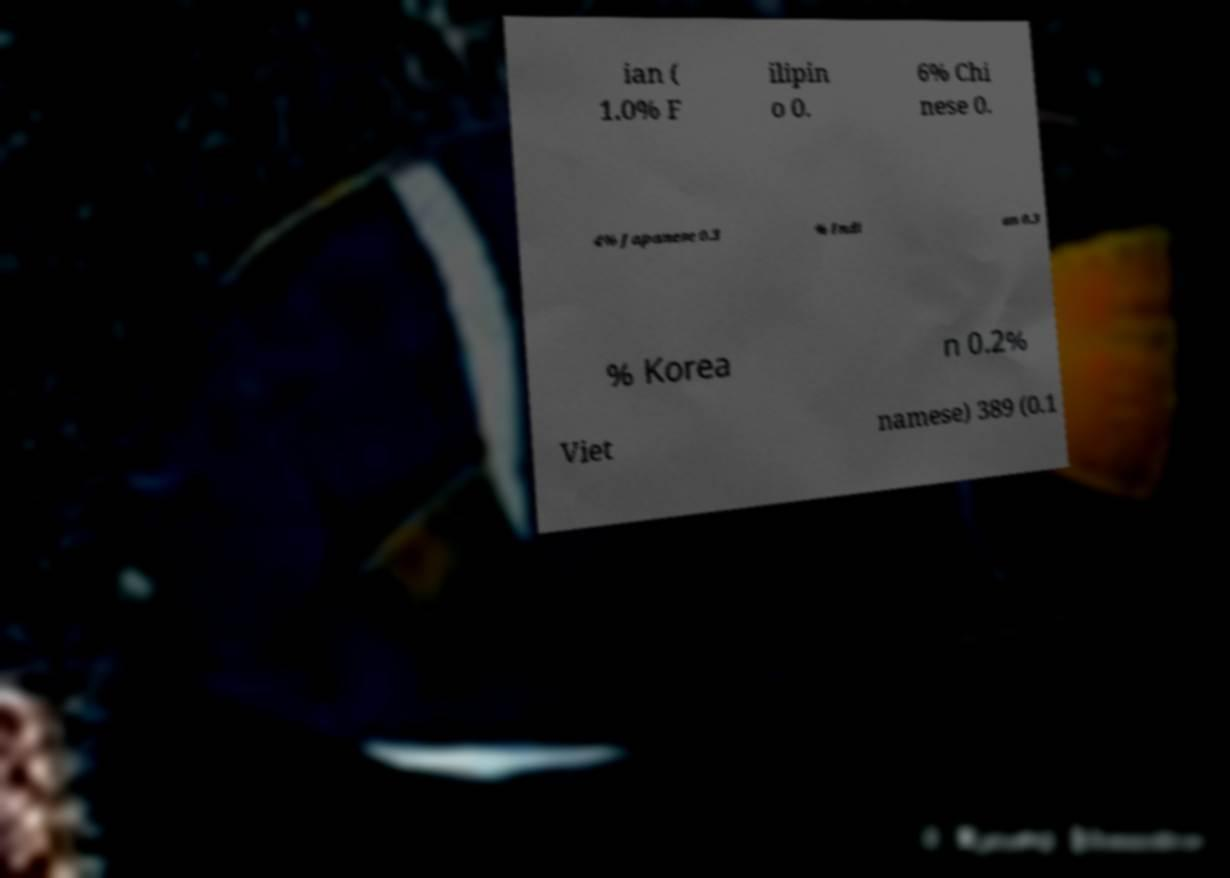For documentation purposes, I need the text within this image transcribed. Could you provide that? ian ( 1.0% F ilipin o 0. 6% Chi nese 0. 4% Japanese 0.3 % Indi an 0.3 % Korea n 0.2% Viet namese) 389 (0.1 